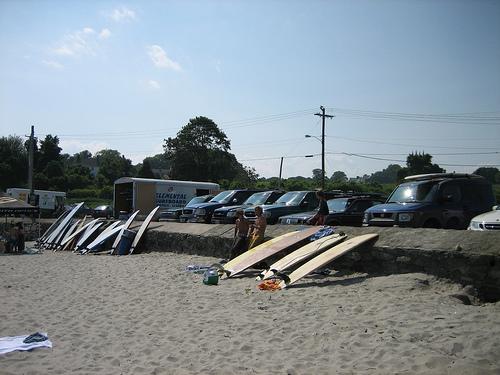Is there a cooler in this picture?
Quick response, please. Yes. Are these surfboards?
Concise answer only. Yes. What are the surfboards resting on?
Concise answer only. Wall. Where are the cars parked?
Concise answer only. Beach. 